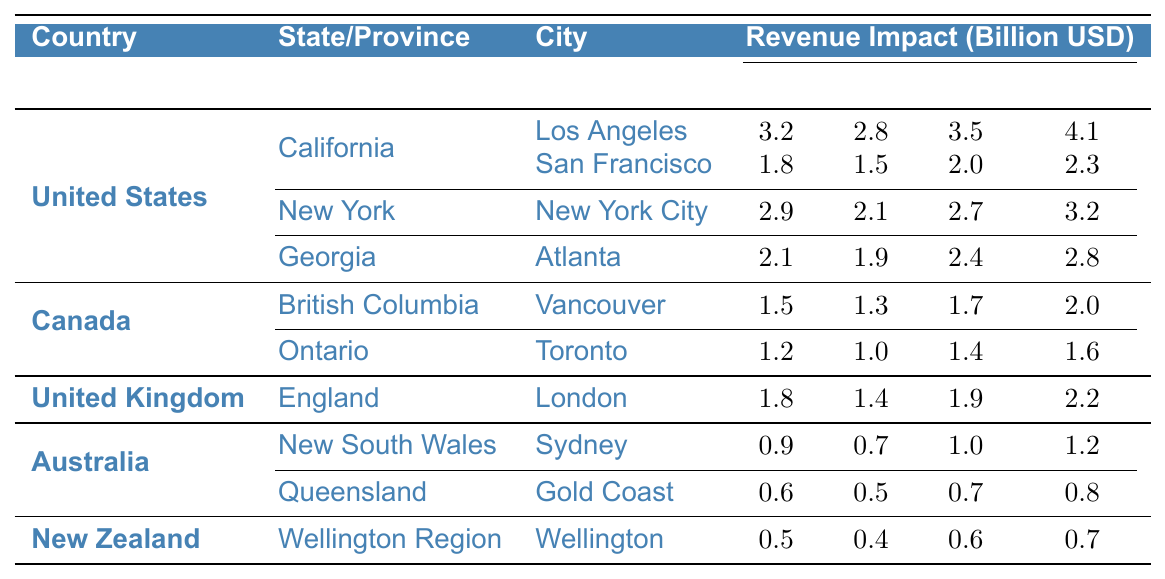What is the revenue impact of filming in Los Angeles in 2022? According to the table, the revenue impact for Los Angeles in 2022 is listed as 4.1 billion USD.
Answer: 4.1 billion USD Which city had the highest revenue impact in New York in 2021? The table shows that New York City had a revenue impact of 2.7 billion USD in 2021, which is higher than any other city listed in New York.
Answer: New York City What was the total revenue impact for all California cities in 2022? The total revenue impact for California in 2022 can be found by summing the values for Los Angeles (4.1 billion) and San Francisco (2.3 billion), resulting in 4.1 + 2.3 = 6.4 billion USD.
Answer: 6.4 billion USD Did Vancouver's revenue impact increase every year from 2019 to 2022? By examining the values, Vancouver's revenue impact was 1.5 billion in 2019, 1.3 billion in 2020, 1.7 billion in 2021, and 2.0 billion in 2022; it did not increase from 2019 to 2020, so the answer is no.
Answer: No What is the average revenue impact for Atlanta from 2019 to 2022? The revenue impacts for Atlanta are 2.1 billion (2019), 1.9 billion (2020), 2.4 billion (2021), and 2.8 billion (2022). First, sum these values: 2.1 + 1.9 + 2.4 + 2.8 = 10.2 billion. Then divide by the 4 years to find the average: 10.2 / 4 = 2.55 billion USD.
Answer: 2.55 billion USD Which country had the lowest overall revenue impact in 2020? We must compare the total revenue impacts for all countries in 2020. The totals are: United States: 2.8 + 2.1 + 1.9 + 1.5 = 8.3 billion, Canada: 1.3 + 1.0 = 2.3 billion, United Kingdom: 1.4 billion, Australia: 0.7 + 0.5 = 1.2 billion, and New Zealand: 0.4 billion. The lowest is Australia with 1.2 billion USD.
Answer: Australia Did the revenue impact for the Gold Coast increase from 2019 to 2022? According to the table, the revenue impact for the Gold Coast is 0.6 billion in 2019, 0.5 billion in 2020, 0.7 billion in 2021, and 0.8 billion in 2022; thus, it increased.
Answer: Yes Which province in Canada had a higher revenue impact in 2021? The revenue impacts for British Columbia (Vancouver: 1.7 billion) and Ontario (Toronto: 1.4 billion) are compared; since 1.7 billion > 1.4 billion, British Columbia had a higher revenue impact.
Answer: British Columbia What was the percentage increase in revenue impact for Sydney from 2021 to 2022? For Sydney, the revenue impact increased from 1.0 billion in 2021 to 1.2 billion in 2022. The increase is 1.2 - 1.0 = 0.2 billion. To find the percentage increase: (0.2 / 1.0) * 100 = 20%.
Answer: 20% 